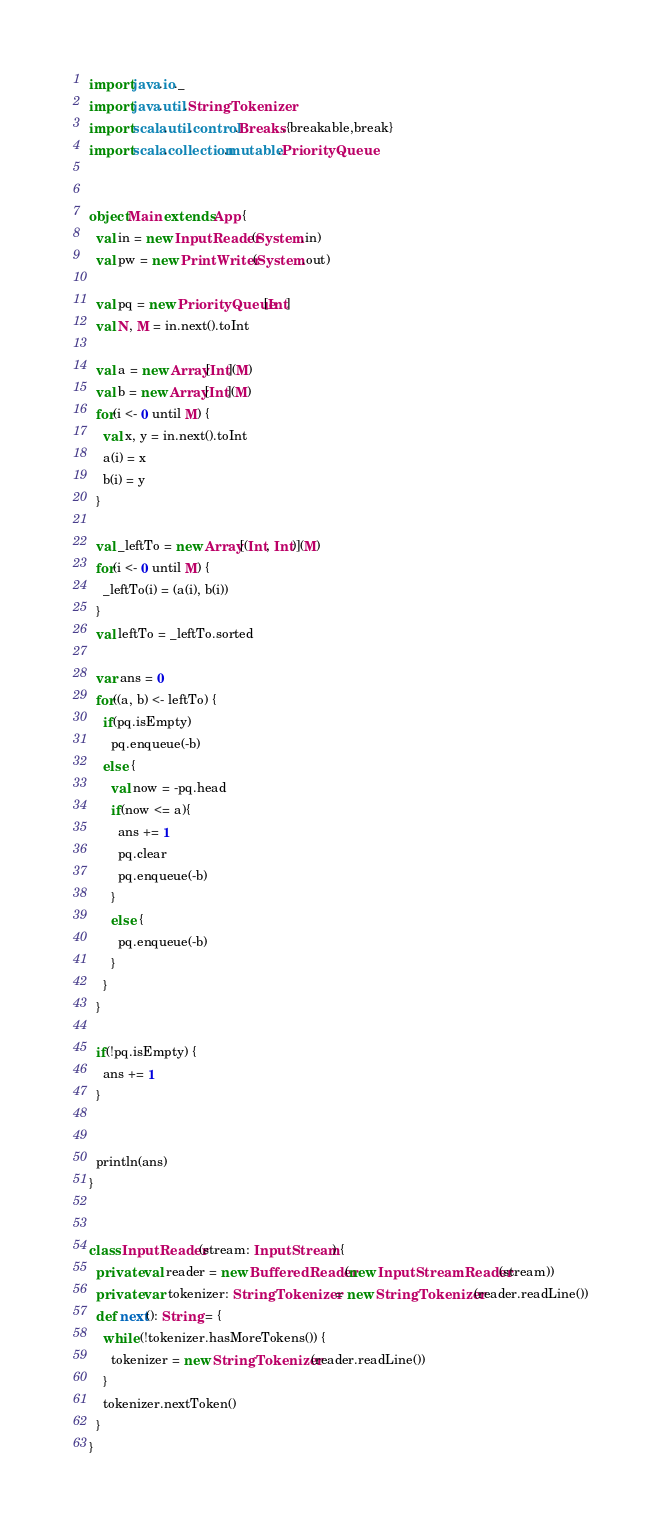Convert code to text. <code><loc_0><loc_0><loc_500><loc_500><_Scala_>import java.io._
import java.util.StringTokenizer
import scala.util.control.Breaks.{breakable,break}
import scala.collection.mutable.PriorityQueue


object Main extends App {
  val in = new InputReader(System.in)
  val pw = new PrintWriter(System.out)

  val pq = new PriorityQueue[Int]
  val N, M = in.next().toInt

  val a = new Array[Int](M)
  val b = new Array[Int](M)
  for(i <- 0 until M) {
    val x, y = in.next().toInt
    a(i) = x
    b(i) = y
  }

  val _leftTo = new Array[(Int, Int)](M)
  for(i <- 0 until M) {
    _leftTo(i) = (a(i), b(i))
  }
  val leftTo = _leftTo.sorted

  var ans = 0
  for((a, b) <- leftTo) {
    if(pq.isEmpty)
      pq.enqueue(-b)
    else {
      val now = -pq.head
      if(now <= a){
        ans += 1
        pq.clear
        pq.enqueue(-b)
      }
      else {
        pq.enqueue(-b)
      }
    }
  }

  if(!pq.isEmpty) {
    ans += 1
  }
    

  println(ans)
}


class InputReader(stream: InputStream) {
  private val reader = new BufferedReader(new InputStreamReader(stream))
  private var tokenizer: StringTokenizer = new StringTokenizer(reader.readLine())
  def next(): String = {
    while (!tokenizer.hasMoreTokens()) {
      tokenizer = new StringTokenizer(reader.readLine())
    }
    tokenizer.nextToken()
  }
}
</code> 